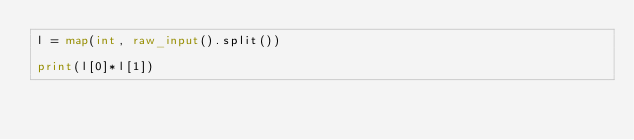<code> <loc_0><loc_0><loc_500><loc_500><_Python_>l = map(int, raw_input().split())

print(l[0]*l[1])

</code> 